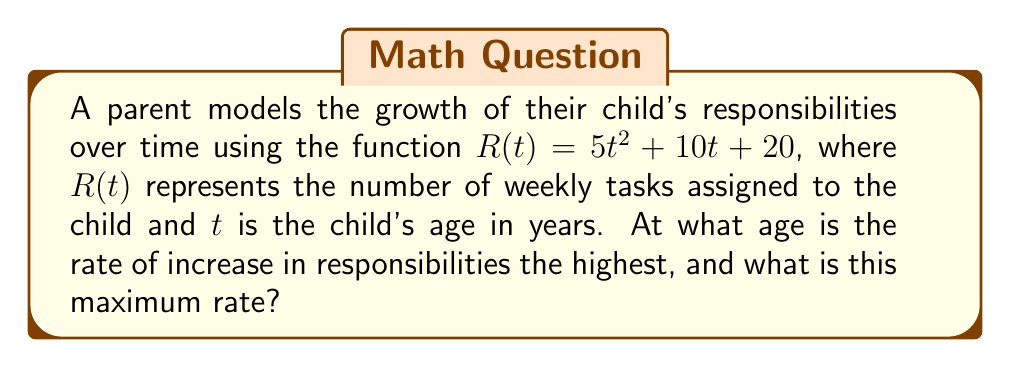Give your solution to this math problem. To solve this problem, we need to follow these steps:

1) The rate of change in responsibilities is given by the derivative of $R(t)$ with respect to $t$. Let's call this $R'(t)$.

   $R'(t) = \frac{d}{dt}(5t^2 + 10t + 20) = 10t + 10$

2) The rate of increase is highest when $R'(t)$ is at its maximum. To find this, we need to find the derivative of $R'(t)$, which we'll call $R''(t)$.

   $R''(t) = \frac{d}{dt}(10t + 10) = 10$

3) Since $R''(t)$ is a constant (10), it means that $R'(t)$ is always increasing at a constant rate. The rate of increase in responsibilities is therefore highest at the maximum age considered.

4) Assuming we're considering childhood up to age 18, the maximum rate would occur at $t = 18$.

5) To find the maximum rate, we plug $t = 18$ into $R'(t)$:

   $R'(18) = 10(18) + 10 = 180 + 10 = 190$

Therefore, the rate of increase in responsibilities is highest at age 18, and the maximum rate is 190 tasks per year.
Answer: Age: 18 years; Maximum rate: 190 tasks/year 